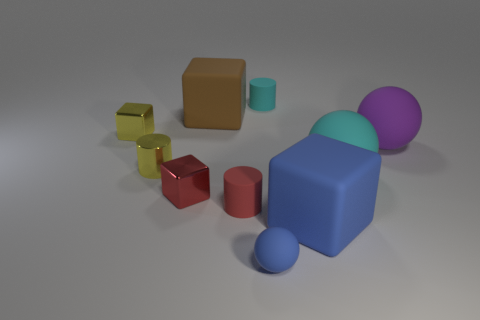Is the shape of the cyan matte object that is in front of the yellow metallic cylinder the same as  the brown object?
Keep it short and to the point. No. Do the tiny cylinder to the right of the red matte thing and the tiny blue ball have the same material?
Keep it short and to the point. Yes. What material is the cyan object that is in front of the thing that is on the right side of the cyan rubber thing right of the cyan matte cylinder made of?
Provide a succinct answer. Rubber. What number of other objects are there of the same shape as the large cyan object?
Give a very brief answer. 2. There is a tiny metallic cube that is in front of the purple sphere; what is its color?
Keep it short and to the point. Red. What number of matte spheres are behind the small thing that is on the right side of the blue matte thing to the left of the cyan rubber cylinder?
Keep it short and to the point. 0. There is a matte thing that is behind the big brown rubber object; what number of blue matte balls are on the left side of it?
Offer a very short reply. 1. There is a purple sphere; how many blue matte blocks are behind it?
Keep it short and to the point. 0. How many other objects are there of the same size as the purple ball?
Offer a very short reply. 3. What is the size of the brown rubber object that is the same shape as the big blue object?
Your answer should be very brief. Large. 